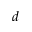Convert formula to latex. <formula><loc_0><loc_0><loc_500><loc_500>d</formula> 